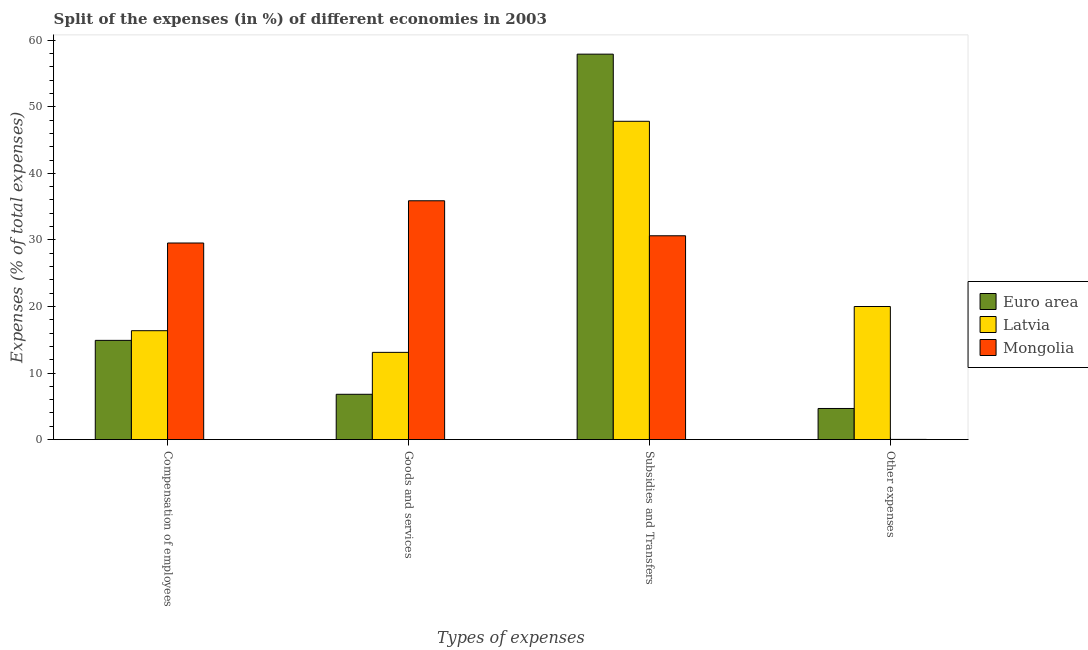How many different coloured bars are there?
Give a very brief answer. 3. How many groups of bars are there?
Ensure brevity in your answer.  4. What is the label of the 3rd group of bars from the left?
Your answer should be compact. Subsidies and Transfers. What is the percentage of amount spent on other expenses in Latvia?
Offer a very short reply. 20. Across all countries, what is the maximum percentage of amount spent on other expenses?
Offer a very short reply. 20. Across all countries, what is the minimum percentage of amount spent on compensation of employees?
Give a very brief answer. 14.91. In which country was the percentage of amount spent on other expenses maximum?
Give a very brief answer. Latvia. In which country was the percentage of amount spent on compensation of employees minimum?
Your answer should be very brief. Euro area. What is the total percentage of amount spent on goods and services in the graph?
Offer a very short reply. 55.8. What is the difference between the percentage of amount spent on subsidies in Euro area and that in Mongolia?
Provide a short and direct response. 27.29. What is the difference between the percentage of amount spent on goods and services in Euro area and the percentage of amount spent on compensation of employees in Mongolia?
Provide a short and direct response. -22.73. What is the average percentage of amount spent on goods and services per country?
Your response must be concise. 18.6. What is the difference between the percentage of amount spent on goods and services and percentage of amount spent on compensation of employees in Latvia?
Your response must be concise. -3.26. In how many countries, is the percentage of amount spent on goods and services greater than 42 %?
Give a very brief answer. 0. What is the ratio of the percentage of amount spent on goods and services in Euro area to that in Mongolia?
Your answer should be compact. 0.19. Is the percentage of amount spent on other expenses in Latvia less than that in Euro area?
Give a very brief answer. No. What is the difference between the highest and the second highest percentage of amount spent on compensation of employees?
Provide a succinct answer. 13.18. What is the difference between the highest and the lowest percentage of amount spent on other expenses?
Your response must be concise. 19.97. Is it the case that in every country, the sum of the percentage of amount spent on goods and services and percentage of amount spent on subsidies is greater than the sum of percentage of amount spent on compensation of employees and percentage of amount spent on other expenses?
Provide a succinct answer. Yes. What does the 2nd bar from the left in Goods and services represents?
Make the answer very short. Latvia. What does the 1st bar from the right in Goods and services represents?
Ensure brevity in your answer.  Mongolia. How many countries are there in the graph?
Give a very brief answer. 3. Are the values on the major ticks of Y-axis written in scientific E-notation?
Your answer should be compact. No. What is the title of the graph?
Give a very brief answer. Split of the expenses (in %) of different economies in 2003. What is the label or title of the X-axis?
Your answer should be very brief. Types of expenses. What is the label or title of the Y-axis?
Give a very brief answer. Expenses (% of total expenses). What is the Expenses (% of total expenses) of Euro area in Compensation of employees?
Your response must be concise. 14.91. What is the Expenses (% of total expenses) of Latvia in Compensation of employees?
Keep it short and to the point. 16.36. What is the Expenses (% of total expenses) in Mongolia in Compensation of employees?
Your answer should be compact. 29.54. What is the Expenses (% of total expenses) in Euro area in Goods and services?
Provide a succinct answer. 6.81. What is the Expenses (% of total expenses) in Latvia in Goods and services?
Provide a succinct answer. 13.11. What is the Expenses (% of total expenses) in Mongolia in Goods and services?
Give a very brief answer. 35.88. What is the Expenses (% of total expenses) in Euro area in Subsidies and Transfers?
Make the answer very short. 57.91. What is the Expenses (% of total expenses) in Latvia in Subsidies and Transfers?
Ensure brevity in your answer.  47.83. What is the Expenses (% of total expenses) of Mongolia in Subsidies and Transfers?
Your response must be concise. 30.62. What is the Expenses (% of total expenses) of Euro area in Other expenses?
Provide a succinct answer. 4.68. What is the Expenses (% of total expenses) of Latvia in Other expenses?
Provide a succinct answer. 20. What is the Expenses (% of total expenses) of Mongolia in Other expenses?
Your answer should be very brief. 0.03. Across all Types of expenses, what is the maximum Expenses (% of total expenses) in Euro area?
Offer a very short reply. 57.91. Across all Types of expenses, what is the maximum Expenses (% of total expenses) of Latvia?
Your answer should be compact. 47.83. Across all Types of expenses, what is the maximum Expenses (% of total expenses) of Mongolia?
Offer a very short reply. 35.88. Across all Types of expenses, what is the minimum Expenses (% of total expenses) of Euro area?
Provide a short and direct response. 4.68. Across all Types of expenses, what is the minimum Expenses (% of total expenses) in Latvia?
Provide a short and direct response. 13.11. Across all Types of expenses, what is the minimum Expenses (% of total expenses) of Mongolia?
Your answer should be very brief. 0.03. What is the total Expenses (% of total expenses) in Euro area in the graph?
Offer a terse response. 84.31. What is the total Expenses (% of total expenses) of Latvia in the graph?
Keep it short and to the point. 97.29. What is the total Expenses (% of total expenses) in Mongolia in the graph?
Your answer should be very brief. 96.08. What is the difference between the Expenses (% of total expenses) in Euro area in Compensation of employees and that in Goods and services?
Offer a very short reply. 8.1. What is the difference between the Expenses (% of total expenses) in Latvia in Compensation of employees and that in Goods and services?
Your answer should be compact. 3.26. What is the difference between the Expenses (% of total expenses) in Mongolia in Compensation of employees and that in Goods and services?
Provide a short and direct response. -6.35. What is the difference between the Expenses (% of total expenses) of Euro area in Compensation of employees and that in Subsidies and Transfers?
Give a very brief answer. -43. What is the difference between the Expenses (% of total expenses) in Latvia in Compensation of employees and that in Subsidies and Transfers?
Offer a terse response. -31.46. What is the difference between the Expenses (% of total expenses) in Mongolia in Compensation of employees and that in Subsidies and Transfers?
Offer a terse response. -1.08. What is the difference between the Expenses (% of total expenses) of Euro area in Compensation of employees and that in Other expenses?
Provide a succinct answer. 10.23. What is the difference between the Expenses (% of total expenses) in Latvia in Compensation of employees and that in Other expenses?
Offer a very short reply. -3.64. What is the difference between the Expenses (% of total expenses) of Mongolia in Compensation of employees and that in Other expenses?
Keep it short and to the point. 29.51. What is the difference between the Expenses (% of total expenses) of Euro area in Goods and services and that in Subsidies and Transfers?
Provide a short and direct response. -51.1. What is the difference between the Expenses (% of total expenses) in Latvia in Goods and services and that in Subsidies and Transfers?
Your response must be concise. -34.72. What is the difference between the Expenses (% of total expenses) in Mongolia in Goods and services and that in Subsidies and Transfers?
Make the answer very short. 5.26. What is the difference between the Expenses (% of total expenses) of Euro area in Goods and services and that in Other expenses?
Offer a terse response. 2.13. What is the difference between the Expenses (% of total expenses) in Latvia in Goods and services and that in Other expenses?
Your answer should be very brief. -6.89. What is the difference between the Expenses (% of total expenses) in Mongolia in Goods and services and that in Other expenses?
Offer a very short reply. 35.85. What is the difference between the Expenses (% of total expenses) of Euro area in Subsidies and Transfers and that in Other expenses?
Offer a very short reply. 53.24. What is the difference between the Expenses (% of total expenses) in Latvia in Subsidies and Transfers and that in Other expenses?
Offer a very short reply. 27.83. What is the difference between the Expenses (% of total expenses) of Mongolia in Subsidies and Transfers and that in Other expenses?
Make the answer very short. 30.59. What is the difference between the Expenses (% of total expenses) of Euro area in Compensation of employees and the Expenses (% of total expenses) of Latvia in Goods and services?
Make the answer very short. 1.8. What is the difference between the Expenses (% of total expenses) of Euro area in Compensation of employees and the Expenses (% of total expenses) of Mongolia in Goods and services?
Your answer should be very brief. -20.97. What is the difference between the Expenses (% of total expenses) of Latvia in Compensation of employees and the Expenses (% of total expenses) of Mongolia in Goods and services?
Make the answer very short. -19.52. What is the difference between the Expenses (% of total expenses) of Euro area in Compensation of employees and the Expenses (% of total expenses) of Latvia in Subsidies and Transfers?
Provide a short and direct response. -32.91. What is the difference between the Expenses (% of total expenses) in Euro area in Compensation of employees and the Expenses (% of total expenses) in Mongolia in Subsidies and Transfers?
Your response must be concise. -15.71. What is the difference between the Expenses (% of total expenses) of Latvia in Compensation of employees and the Expenses (% of total expenses) of Mongolia in Subsidies and Transfers?
Ensure brevity in your answer.  -14.26. What is the difference between the Expenses (% of total expenses) in Euro area in Compensation of employees and the Expenses (% of total expenses) in Latvia in Other expenses?
Your answer should be very brief. -5.09. What is the difference between the Expenses (% of total expenses) in Euro area in Compensation of employees and the Expenses (% of total expenses) in Mongolia in Other expenses?
Give a very brief answer. 14.88. What is the difference between the Expenses (% of total expenses) in Latvia in Compensation of employees and the Expenses (% of total expenses) in Mongolia in Other expenses?
Provide a succinct answer. 16.33. What is the difference between the Expenses (% of total expenses) in Euro area in Goods and services and the Expenses (% of total expenses) in Latvia in Subsidies and Transfers?
Make the answer very short. -41.02. What is the difference between the Expenses (% of total expenses) of Euro area in Goods and services and the Expenses (% of total expenses) of Mongolia in Subsidies and Transfers?
Your answer should be very brief. -23.82. What is the difference between the Expenses (% of total expenses) in Latvia in Goods and services and the Expenses (% of total expenses) in Mongolia in Subsidies and Transfers?
Offer a terse response. -17.52. What is the difference between the Expenses (% of total expenses) in Euro area in Goods and services and the Expenses (% of total expenses) in Latvia in Other expenses?
Your answer should be compact. -13.19. What is the difference between the Expenses (% of total expenses) in Euro area in Goods and services and the Expenses (% of total expenses) in Mongolia in Other expenses?
Your response must be concise. 6.78. What is the difference between the Expenses (% of total expenses) in Latvia in Goods and services and the Expenses (% of total expenses) in Mongolia in Other expenses?
Provide a succinct answer. 13.08. What is the difference between the Expenses (% of total expenses) in Euro area in Subsidies and Transfers and the Expenses (% of total expenses) in Latvia in Other expenses?
Provide a short and direct response. 37.92. What is the difference between the Expenses (% of total expenses) in Euro area in Subsidies and Transfers and the Expenses (% of total expenses) in Mongolia in Other expenses?
Make the answer very short. 57.88. What is the difference between the Expenses (% of total expenses) of Latvia in Subsidies and Transfers and the Expenses (% of total expenses) of Mongolia in Other expenses?
Provide a succinct answer. 47.8. What is the average Expenses (% of total expenses) of Euro area per Types of expenses?
Ensure brevity in your answer.  21.08. What is the average Expenses (% of total expenses) in Latvia per Types of expenses?
Your response must be concise. 24.32. What is the average Expenses (% of total expenses) in Mongolia per Types of expenses?
Give a very brief answer. 24.02. What is the difference between the Expenses (% of total expenses) in Euro area and Expenses (% of total expenses) in Latvia in Compensation of employees?
Give a very brief answer. -1.45. What is the difference between the Expenses (% of total expenses) of Euro area and Expenses (% of total expenses) of Mongolia in Compensation of employees?
Offer a very short reply. -14.63. What is the difference between the Expenses (% of total expenses) of Latvia and Expenses (% of total expenses) of Mongolia in Compensation of employees?
Provide a short and direct response. -13.18. What is the difference between the Expenses (% of total expenses) of Euro area and Expenses (% of total expenses) of Latvia in Goods and services?
Offer a terse response. -6.3. What is the difference between the Expenses (% of total expenses) of Euro area and Expenses (% of total expenses) of Mongolia in Goods and services?
Provide a succinct answer. -29.08. What is the difference between the Expenses (% of total expenses) in Latvia and Expenses (% of total expenses) in Mongolia in Goods and services?
Ensure brevity in your answer.  -22.78. What is the difference between the Expenses (% of total expenses) in Euro area and Expenses (% of total expenses) in Latvia in Subsidies and Transfers?
Ensure brevity in your answer.  10.09. What is the difference between the Expenses (% of total expenses) of Euro area and Expenses (% of total expenses) of Mongolia in Subsidies and Transfers?
Provide a succinct answer. 27.29. What is the difference between the Expenses (% of total expenses) of Latvia and Expenses (% of total expenses) of Mongolia in Subsidies and Transfers?
Your answer should be compact. 17.2. What is the difference between the Expenses (% of total expenses) in Euro area and Expenses (% of total expenses) in Latvia in Other expenses?
Provide a succinct answer. -15.32. What is the difference between the Expenses (% of total expenses) in Euro area and Expenses (% of total expenses) in Mongolia in Other expenses?
Offer a very short reply. 4.65. What is the difference between the Expenses (% of total expenses) in Latvia and Expenses (% of total expenses) in Mongolia in Other expenses?
Make the answer very short. 19.97. What is the ratio of the Expenses (% of total expenses) in Euro area in Compensation of employees to that in Goods and services?
Offer a terse response. 2.19. What is the ratio of the Expenses (% of total expenses) of Latvia in Compensation of employees to that in Goods and services?
Offer a very short reply. 1.25. What is the ratio of the Expenses (% of total expenses) of Mongolia in Compensation of employees to that in Goods and services?
Provide a succinct answer. 0.82. What is the ratio of the Expenses (% of total expenses) of Euro area in Compensation of employees to that in Subsidies and Transfers?
Offer a terse response. 0.26. What is the ratio of the Expenses (% of total expenses) in Latvia in Compensation of employees to that in Subsidies and Transfers?
Keep it short and to the point. 0.34. What is the ratio of the Expenses (% of total expenses) of Mongolia in Compensation of employees to that in Subsidies and Transfers?
Ensure brevity in your answer.  0.96. What is the ratio of the Expenses (% of total expenses) of Euro area in Compensation of employees to that in Other expenses?
Give a very brief answer. 3.19. What is the ratio of the Expenses (% of total expenses) in Latvia in Compensation of employees to that in Other expenses?
Provide a short and direct response. 0.82. What is the ratio of the Expenses (% of total expenses) in Mongolia in Compensation of employees to that in Other expenses?
Make the answer very short. 985.07. What is the ratio of the Expenses (% of total expenses) of Euro area in Goods and services to that in Subsidies and Transfers?
Your answer should be very brief. 0.12. What is the ratio of the Expenses (% of total expenses) in Latvia in Goods and services to that in Subsidies and Transfers?
Ensure brevity in your answer.  0.27. What is the ratio of the Expenses (% of total expenses) in Mongolia in Goods and services to that in Subsidies and Transfers?
Give a very brief answer. 1.17. What is the ratio of the Expenses (% of total expenses) of Euro area in Goods and services to that in Other expenses?
Your response must be concise. 1.46. What is the ratio of the Expenses (% of total expenses) of Latvia in Goods and services to that in Other expenses?
Your answer should be very brief. 0.66. What is the ratio of the Expenses (% of total expenses) in Mongolia in Goods and services to that in Other expenses?
Provide a short and direct response. 1196.67. What is the ratio of the Expenses (% of total expenses) of Euro area in Subsidies and Transfers to that in Other expenses?
Your answer should be compact. 12.38. What is the ratio of the Expenses (% of total expenses) in Latvia in Subsidies and Transfers to that in Other expenses?
Make the answer very short. 2.39. What is the ratio of the Expenses (% of total expenses) of Mongolia in Subsidies and Transfers to that in Other expenses?
Provide a succinct answer. 1021.25. What is the difference between the highest and the second highest Expenses (% of total expenses) of Euro area?
Make the answer very short. 43. What is the difference between the highest and the second highest Expenses (% of total expenses) in Latvia?
Give a very brief answer. 27.83. What is the difference between the highest and the second highest Expenses (% of total expenses) of Mongolia?
Give a very brief answer. 5.26. What is the difference between the highest and the lowest Expenses (% of total expenses) of Euro area?
Your answer should be very brief. 53.24. What is the difference between the highest and the lowest Expenses (% of total expenses) in Latvia?
Provide a succinct answer. 34.72. What is the difference between the highest and the lowest Expenses (% of total expenses) in Mongolia?
Provide a short and direct response. 35.85. 